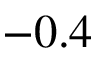<formula> <loc_0><loc_0><loc_500><loc_500>- 0 . 4</formula> 